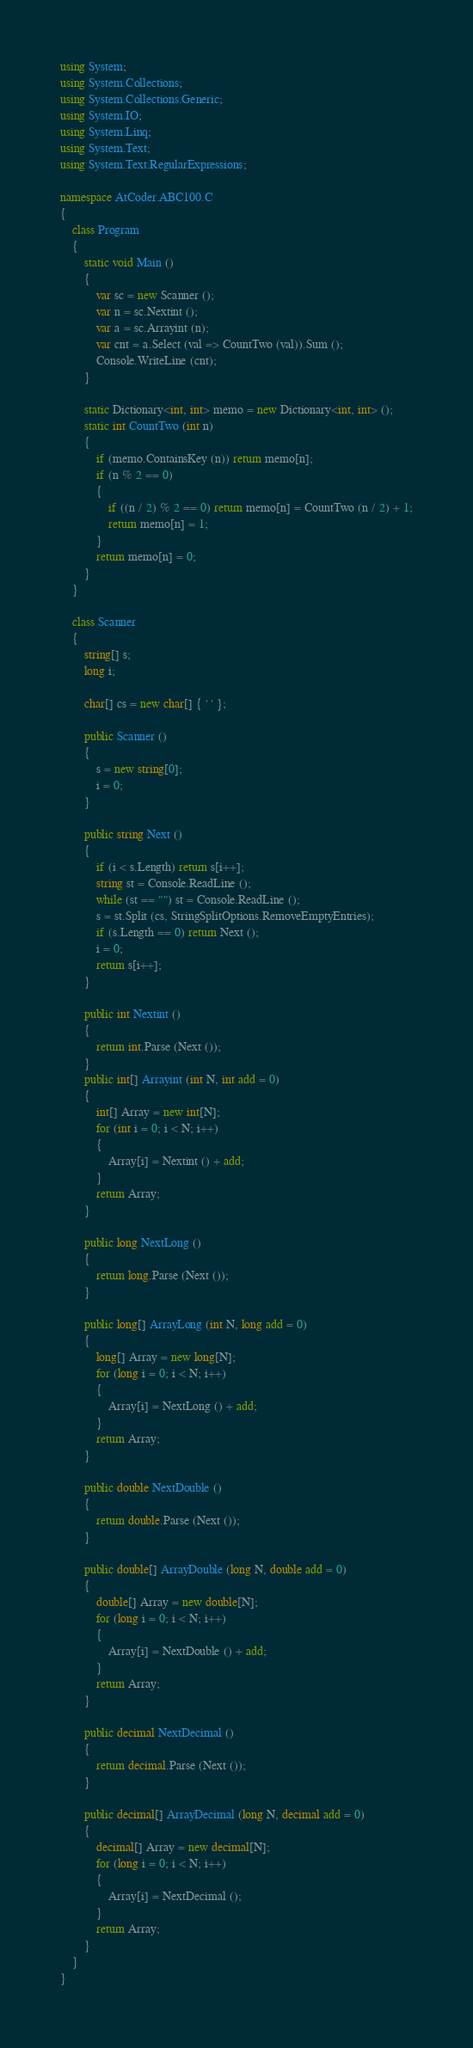<code> <loc_0><loc_0><loc_500><loc_500><_C#_>using System;
using System.Collections;
using System.Collections.Generic;
using System.IO;
using System.Linq;
using System.Text;
using System.Text.RegularExpressions;

namespace AtCoder.ABC100.C
{
    class Program
    {
        static void Main ()
        {
            var sc = new Scanner ();
            var n = sc.Nextint ();
            var a = sc.Arrayint (n);
            var cnt = a.Select (val => CountTwo (val)).Sum ();
            Console.WriteLine (cnt);
        }

        static Dictionary<int, int> memo = new Dictionary<int, int> ();
        static int CountTwo (int n)
        {
            if (memo.ContainsKey (n)) return memo[n];
            if (n % 2 == 0)
            {
                if ((n / 2) % 2 == 0) return memo[n] = CountTwo (n / 2) + 1;
                return memo[n] = 1;
            }
            return memo[n] = 0;
        }
    }

    class Scanner
    {
        string[] s;
        long i;

        char[] cs = new char[] { ' ' };

        public Scanner ()
        {
            s = new string[0];
            i = 0;
        }

        public string Next ()
        {
            if (i < s.Length) return s[i++];
            string st = Console.ReadLine ();
            while (st == "") st = Console.ReadLine ();
            s = st.Split (cs, StringSplitOptions.RemoveEmptyEntries);
            if (s.Length == 0) return Next ();
            i = 0;
            return s[i++];
        }

        public int Nextint ()
        {
            return int.Parse (Next ());
        }
        public int[] Arrayint (int N, int add = 0)
        {
            int[] Array = new int[N];
            for (int i = 0; i < N; i++)
            {
                Array[i] = Nextint () + add;
            }
            return Array;
        }

        public long NextLong ()
        {
            return long.Parse (Next ());
        }

        public long[] ArrayLong (int N, long add = 0)
        {
            long[] Array = new long[N];
            for (long i = 0; i < N; i++)
            {
                Array[i] = NextLong () + add;
            }
            return Array;
        }

        public double NextDouble ()
        {
            return double.Parse (Next ());
        }

        public double[] ArrayDouble (long N, double add = 0)
        {
            double[] Array = new double[N];
            for (long i = 0; i < N; i++)
            {
                Array[i] = NextDouble () + add;
            }
            return Array;
        }

        public decimal NextDecimal ()
        {
            return decimal.Parse (Next ());
        }

        public decimal[] ArrayDecimal (long N, decimal add = 0)
        {
            decimal[] Array = new decimal[N];
            for (long i = 0; i < N; i++)
            {
                Array[i] = NextDecimal ();
            }
            return Array;
        }
    }
}</code> 